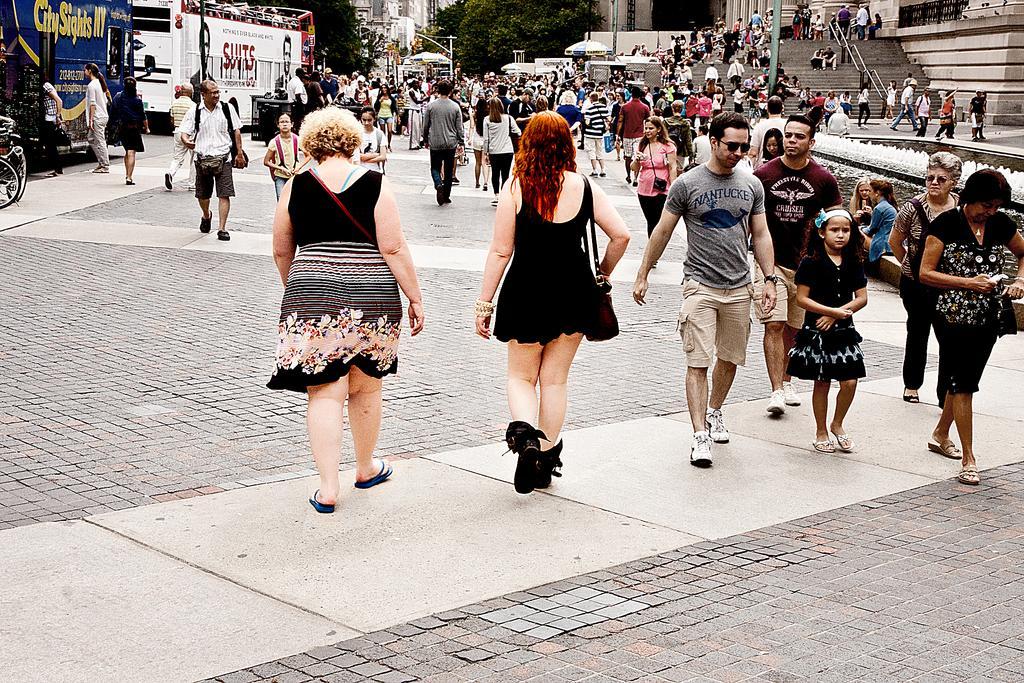Please provide a concise description of this image. In this image I can see group of people walking on the road. In front the person is wearing black color dress and I can also see few vehicles in multicolor, few light poles, buildings in cream and white color and trees in green color. 